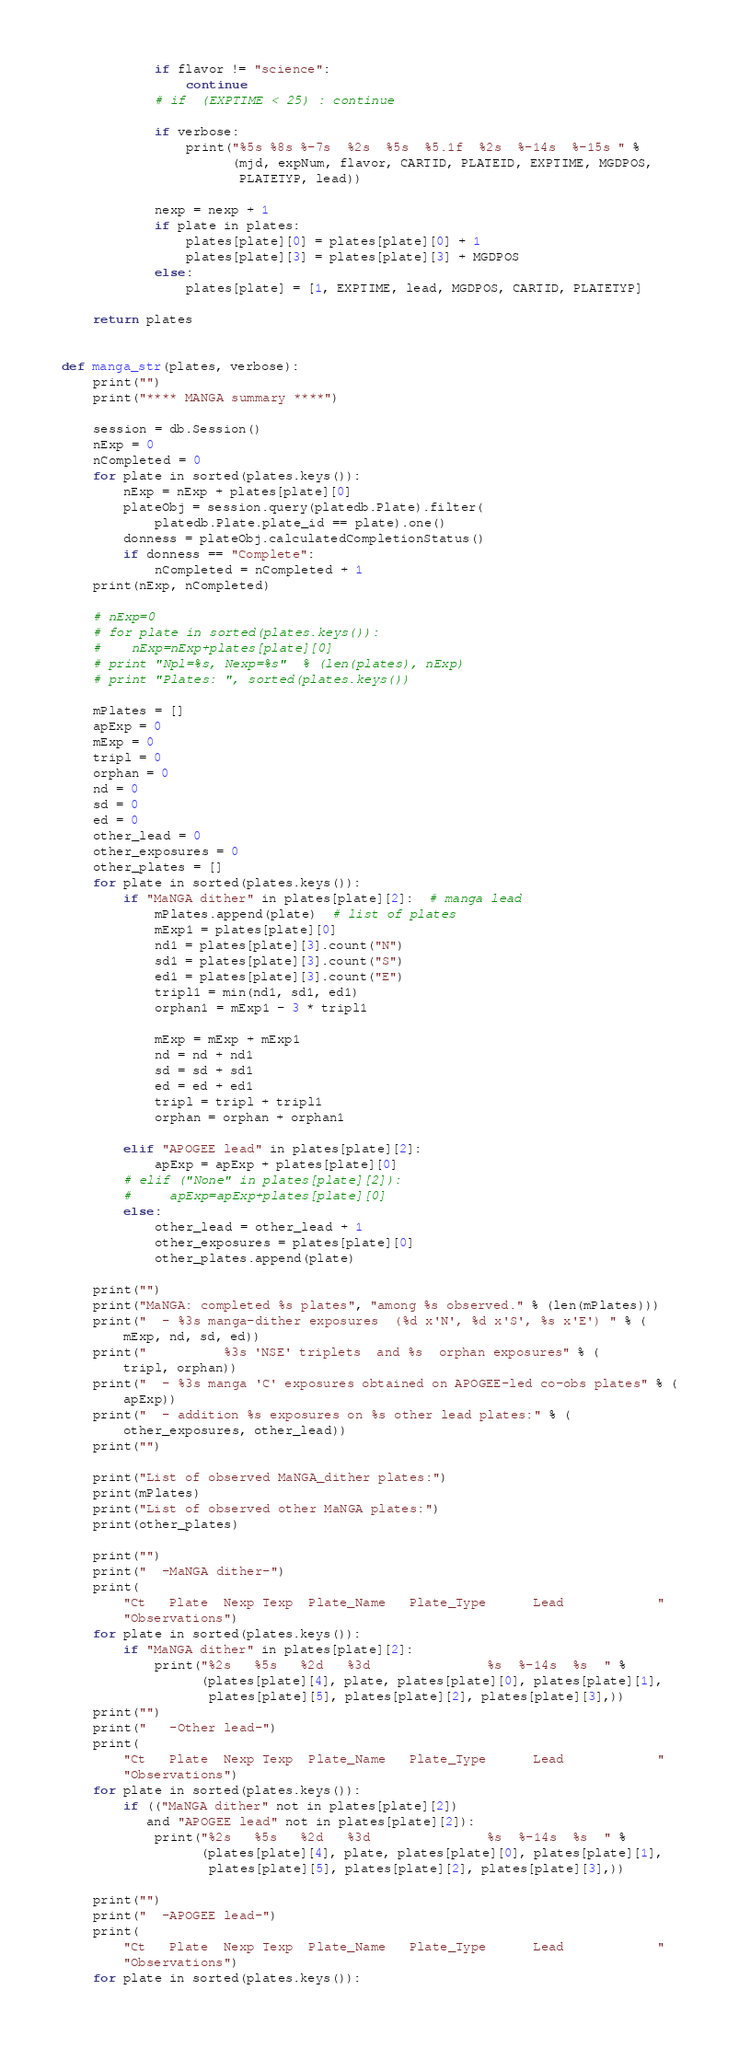<code> <loc_0><loc_0><loc_500><loc_500><_Python_>            if flavor != "science":
                continue
            # if  (EXPTIME < 25) : continue

            if verbose:
                print("%5s %8s %-7s  %2s  %5s  %5.1f  %2s  %-14s  %-15s " %
                      (mjd, expNum, flavor, CARTID, PLATEID, EXPTIME, MGDPOS,
                       PLATETYP, lead))

            nexp = nexp + 1
            if plate in plates:
                plates[plate][0] = plates[plate][0] + 1
                plates[plate][3] = plates[plate][3] + MGDPOS
            else:
                plates[plate] = [1, EXPTIME, lead, MGDPOS, CARTID, PLATETYP]

    return plates


def manga_str(plates, verbose):
    print("")
    print("**** MANGA summary ****")

    session = db.Session()
    nExp = 0
    nCompleted = 0
    for plate in sorted(plates.keys()):
        nExp = nExp + plates[plate][0]
        plateObj = session.query(platedb.Plate).filter(
            platedb.Plate.plate_id == plate).one()
        donness = plateObj.calculatedCompletionStatus()
        if donness == "Complete":
            nCompleted = nCompleted + 1
    print(nExp, nCompleted)

    # nExp=0
    # for plate in sorted(plates.keys()):
    #    nExp=nExp+plates[plate][0]
    # print "Npl=%s, Nexp=%s"  % (len(plates), nExp)
    # print "Plates: ", sorted(plates.keys())

    mPlates = []
    apExp = 0
    mExp = 0
    tripl = 0
    orphan = 0
    nd = 0
    sd = 0
    ed = 0
    other_lead = 0
    other_exposures = 0
    other_plates = []
    for plate in sorted(plates.keys()):
        if "MaNGA dither" in plates[plate][2]:  # manga lead
            mPlates.append(plate)  # list of plates
            mExp1 = plates[plate][0]
            nd1 = plates[plate][3].count("N")
            sd1 = plates[plate][3].count("S")
            ed1 = plates[plate][3].count("E")
            tripl1 = min(nd1, sd1, ed1)
            orphan1 = mExp1 - 3 * tripl1

            mExp = mExp + mExp1
            nd = nd + nd1
            sd = sd + sd1
            ed = ed + ed1
            tripl = tripl + tripl1
            orphan = orphan + orphan1

        elif "APOGEE lead" in plates[plate][2]:
            apExp = apExp + plates[plate][0]
        # elif ("None" in plates[plate][2]):
        #     apExp=apExp+plates[plate][0]
        else:
            other_lead = other_lead + 1
            other_exposures = plates[plate][0]
            other_plates.append(plate)

    print("")
    print("MaNGA: completed %s plates", "among %s observed." % (len(mPlates)))
    print("  - %3s manga-dither exposures  (%d x'N', %d x'S', %s x'E') " % (
        mExp, nd, sd, ed))
    print("          %3s 'NSE' triplets  and %s  orphan exposures" % (
        tripl, orphan))
    print("  - %3s manga 'C' exposures obtained on APOGEE-led co-obs plates" % (
        apExp))
    print("  - addition %s exposures on %s other lead plates:" % (
        other_exposures, other_lead))
    print("")

    print("List of observed MaNGA_dither plates:")
    print(mPlates)
    print("List of observed other MaNGA plates:")
    print(other_plates)

    print("")
    print("  -MaNGA dither-")
    print(
        "Ct   Plate  Nexp Texp  Plate_Name   Plate_Type      Lead            "
        "Observations")
    for plate in sorted(plates.keys()):
        if "MaNGA dither" in plates[plate][2]:
            print("%2s   %5s   %2d   %3d               %s  %-14s  %s  " %
                  (plates[plate][4], plate, plates[plate][0], plates[plate][1],
                   plates[plate][5], plates[plate][2], plates[plate][3],))
    print("")
    print("   -Other lead-")
    print(
        "Ct   Plate  Nexp Texp  Plate_Name   Plate_Type      Lead            "
        "Observations")
    for plate in sorted(plates.keys()):
        if (("MaNGA dither" not in plates[plate][2])
           and "APOGEE lead" not in plates[plate][2]):
            print("%2s   %5s   %2d   %3d               %s  %-14s  %s  " %
                  (plates[plate][4], plate, plates[plate][0], plates[plate][1],
                   plates[plate][5], plates[plate][2], plates[plate][3],))

    print("")
    print("  -APOGEE lead-")
    print(
        "Ct   Plate  Nexp Texp  Plate_Name   Plate_Type      Lead            "
        "Observations")
    for plate in sorted(plates.keys()):</code> 